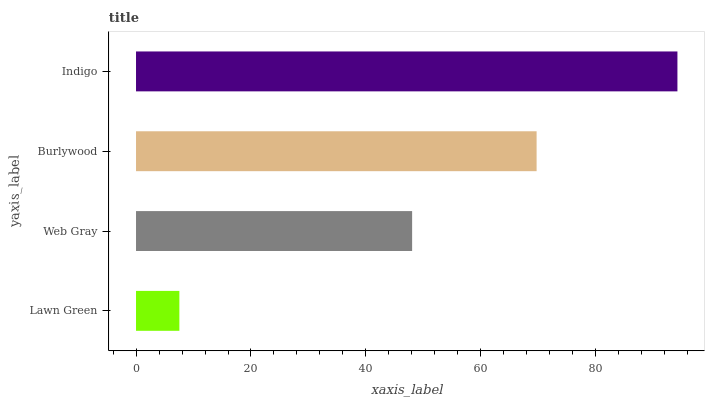Is Lawn Green the minimum?
Answer yes or no. Yes. Is Indigo the maximum?
Answer yes or no. Yes. Is Web Gray the minimum?
Answer yes or no. No. Is Web Gray the maximum?
Answer yes or no. No. Is Web Gray greater than Lawn Green?
Answer yes or no. Yes. Is Lawn Green less than Web Gray?
Answer yes or no. Yes. Is Lawn Green greater than Web Gray?
Answer yes or no. No. Is Web Gray less than Lawn Green?
Answer yes or no. No. Is Burlywood the high median?
Answer yes or no. Yes. Is Web Gray the low median?
Answer yes or no. Yes. Is Lawn Green the high median?
Answer yes or no. No. Is Burlywood the low median?
Answer yes or no. No. 